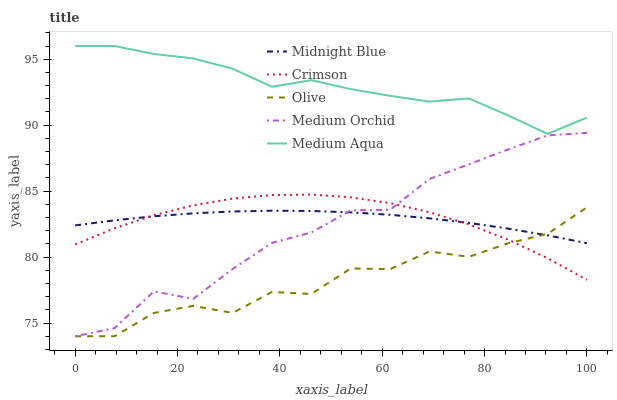Does Medium Orchid have the minimum area under the curve?
Answer yes or no. No. Does Medium Orchid have the maximum area under the curve?
Answer yes or no. No. Is Medium Orchid the smoothest?
Answer yes or no. No. Is Medium Orchid the roughest?
Answer yes or no. No. Does Medium Aqua have the lowest value?
Answer yes or no. No. Does Olive have the highest value?
Answer yes or no. No. Is Midnight Blue less than Medium Aqua?
Answer yes or no. Yes. Is Medium Aqua greater than Crimson?
Answer yes or no. Yes. Does Midnight Blue intersect Medium Aqua?
Answer yes or no. No. 